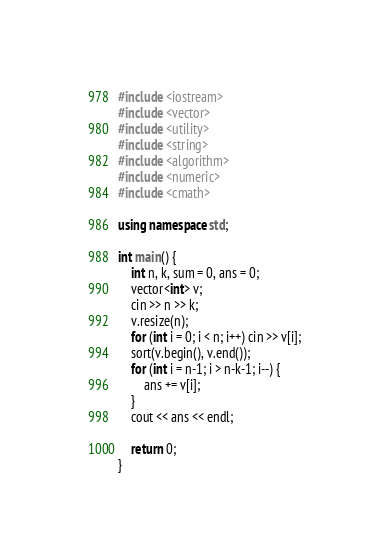<code> <loc_0><loc_0><loc_500><loc_500><_C++_>#include <iostream>
#include <vector>
#include <utility>
#include <string>
#include <algorithm>
#include <numeric>
#include <cmath>

using namespace std;

int main() {
	int n, k, sum = 0, ans = 0;
	vector<int> v;
	cin >> n >> k;
	v.resize(n);
	for (int i = 0; i < n; i++) cin >> v[i];
	sort(v.begin(), v.end());
	for (int i = n-1; i > n-k-1; i--) {
		ans += v[i];
	}
	cout << ans << endl;

	return 0;
}
</code> 